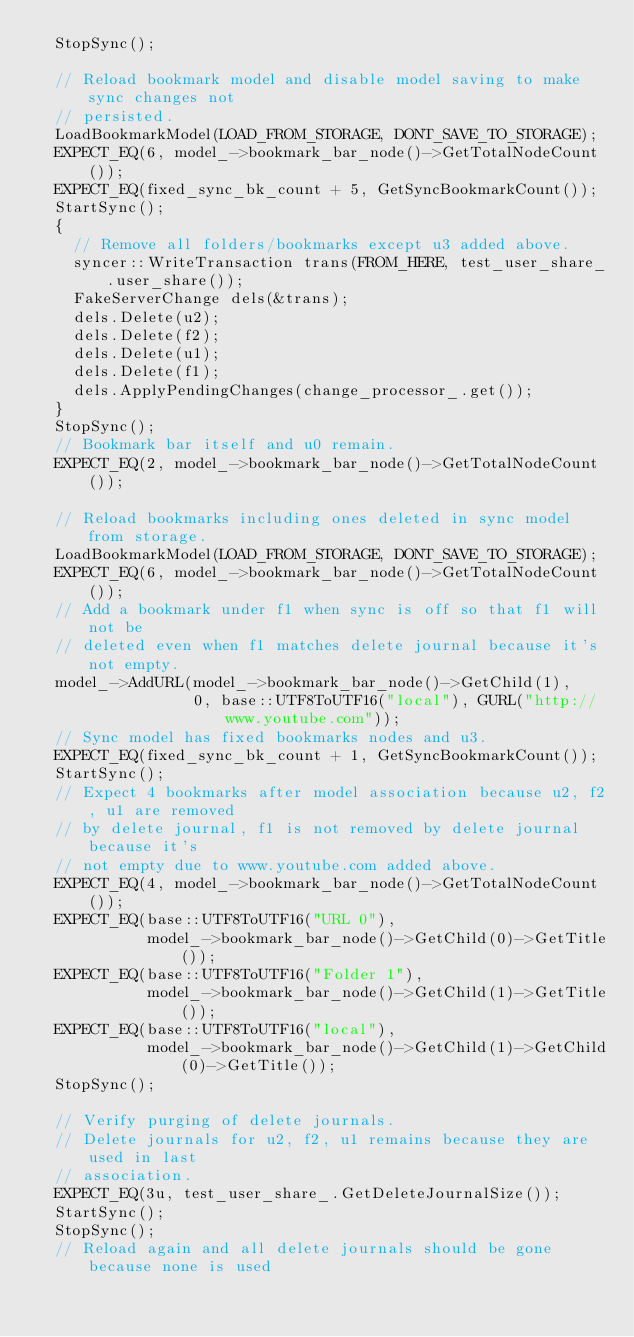<code> <loc_0><loc_0><loc_500><loc_500><_C++_>  StopSync();

  // Reload bookmark model and disable model saving to make sync changes not
  // persisted.
  LoadBookmarkModel(LOAD_FROM_STORAGE, DONT_SAVE_TO_STORAGE);
  EXPECT_EQ(6, model_->bookmark_bar_node()->GetTotalNodeCount());
  EXPECT_EQ(fixed_sync_bk_count + 5, GetSyncBookmarkCount());
  StartSync();
  {
    // Remove all folders/bookmarks except u3 added above.
    syncer::WriteTransaction trans(FROM_HERE, test_user_share_.user_share());
    FakeServerChange dels(&trans);
    dels.Delete(u2);
    dels.Delete(f2);
    dels.Delete(u1);
    dels.Delete(f1);
    dels.ApplyPendingChanges(change_processor_.get());
  }
  StopSync();
  // Bookmark bar itself and u0 remain.
  EXPECT_EQ(2, model_->bookmark_bar_node()->GetTotalNodeCount());

  // Reload bookmarks including ones deleted in sync model from storage.
  LoadBookmarkModel(LOAD_FROM_STORAGE, DONT_SAVE_TO_STORAGE);
  EXPECT_EQ(6, model_->bookmark_bar_node()->GetTotalNodeCount());
  // Add a bookmark under f1 when sync is off so that f1 will not be
  // deleted even when f1 matches delete journal because it's not empty.
  model_->AddURL(model_->bookmark_bar_node()->GetChild(1),
                 0, base::UTF8ToUTF16("local"), GURL("http://www.youtube.com"));
  // Sync model has fixed bookmarks nodes and u3.
  EXPECT_EQ(fixed_sync_bk_count + 1, GetSyncBookmarkCount());
  StartSync();
  // Expect 4 bookmarks after model association because u2, f2, u1 are removed
  // by delete journal, f1 is not removed by delete journal because it's
  // not empty due to www.youtube.com added above.
  EXPECT_EQ(4, model_->bookmark_bar_node()->GetTotalNodeCount());
  EXPECT_EQ(base::UTF8ToUTF16("URL 0"),
            model_->bookmark_bar_node()->GetChild(0)->GetTitle());
  EXPECT_EQ(base::UTF8ToUTF16("Folder 1"),
            model_->bookmark_bar_node()->GetChild(1)->GetTitle());
  EXPECT_EQ(base::UTF8ToUTF16("local"),
            model_->bookmark_bar_node()->GetChild(1)->GetChild(0)->GetTitle());
  StopSync();

  // Verify purging of delete journals.
  // Delete journals for u2, f2, u1 remains because they are used in last
  // association.
  EXPECT_EQ(3u, test_user_share_.GetDeleteJournalSize());
  StartSync();
  StopSync();
  // Reload again and all delete journals should be gone because none is used</code> 